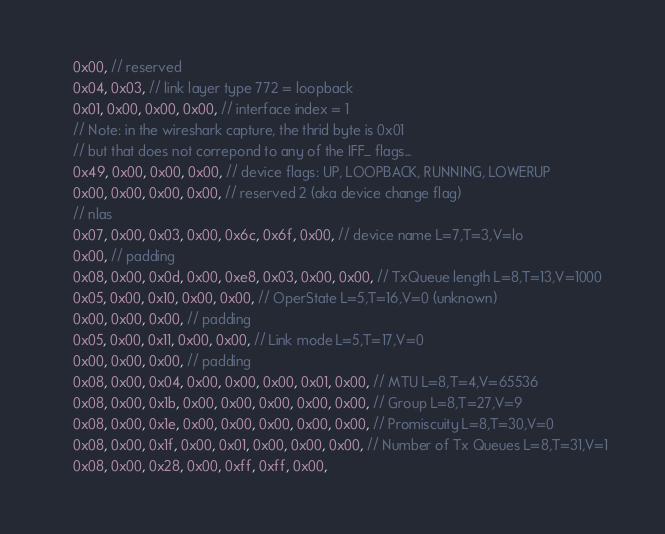<code> <loc_0><loc_0><loc_500><loc_500><_Rust_>    0x00, // reserved
    0x04, 0x03, // link layer type 772 = loopback
    0x01, 0x00, 0x00, 0x00, // interface index = 1
    // Note: in the wireshark capture, the thrid byte is 0x01
    // but that does not correpond to any of the IFF_ flags...
    0x49, 0x00, 0x00, 0x00, // device flags: UP, LOOPBACK, RUNNING, LOWERUP
    0x00, 0x00, 0x00, 0x00, // reserved 2 (aka device change flag)
    // nlas
    0x07, 0x00, 0x03, 0x00, 0x6c, 0x6f, 0x00, // device name L=7,T=3,V=lo
    0x00, // padding
    0x08, 0x00, 0x0d, 0x00, 0xe8, 0x03, 0x00, 0x00, // TxQueue length L=8,T=13,V=1000
    0x05, 0x00, 0x10, 0x00, 0x00, // OperState L=5,T=16,V=0 (unknown)
    0x00, 0x00, 0x00, // padding
    0x05, 0x00, 0x11, 0x00, 0x00, // Link mode L=5,T=17,V=0
    0x00, 0x00, 0x00, // padding
    0x08, 0x00, 0x04, 0x00, 0x00, 0x00, 0x01, 0x00, // MTU L=8,T=4,V=65536
    0x08, 0x00, 0x1b, 0x00, 0x00, 0x00, 0x00, 0x00, // Group L=8,T=27,V=9
    0x08, 0x00, 0x1e, 0x00, 0x00, 0x00, 0x00, 0x00, // Promiscuity L=8,T=30,V=0
    0x08, 0x00, 0x1f, 0x00, 0x01, 0x00, 0x00, 0x00, // Number of Tx Queues L=8,T=31,V=1
    0x08, 0x00, 0x28, 0x00, 0xff, 0xff, 0x00,</code> 